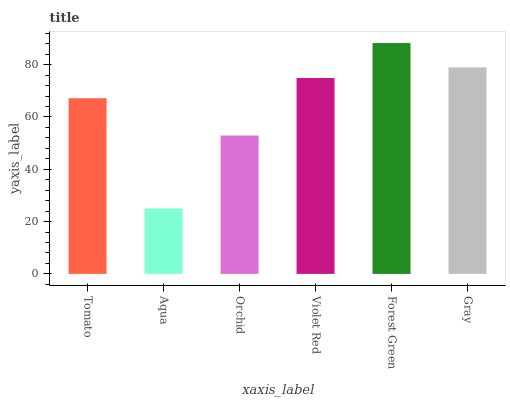Is Aqua the minimum?
Answer yes or no. Yes. Is Forest Green the maximum?
Answer yes or no. Yes. Is Orchid the minimum?
Answer yes or no. No. Is Orchid the maximum?
Answer yes or no. No. Is Orchid greater than Aqua?
Answer yes or no. Yes. Is Aqua less than Orchid?
Answer yes or no. Yes. Is Aqua greater than Orchid?
Answer yes or no. No. Is Orchid less than Aqua?
Answer yes or no. No. Is Violet Red the high median?
Answer yes or no. Yes. Is Tomato the low median?
Answer yes or no. Yes. Is Forest Green the high median?
Answer yes or no. No. Is Aqua the low median?
Answer yes or no. No. 